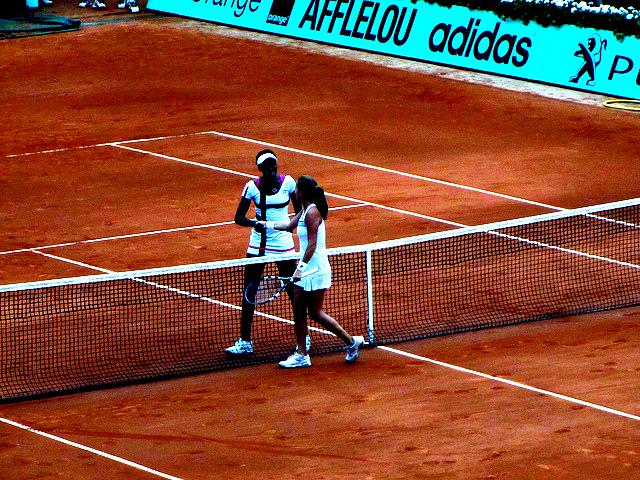How would you describe the lighting in the image? A. Harsh B. Average C. Dim The lighting in the image appears to be Average, as indicated by the shadows under the players and the consistent illumination across the clay court. There's enough light to see details clearly without any harsh glare or extreme contrast that would suggest overly bright or dim conditions. 